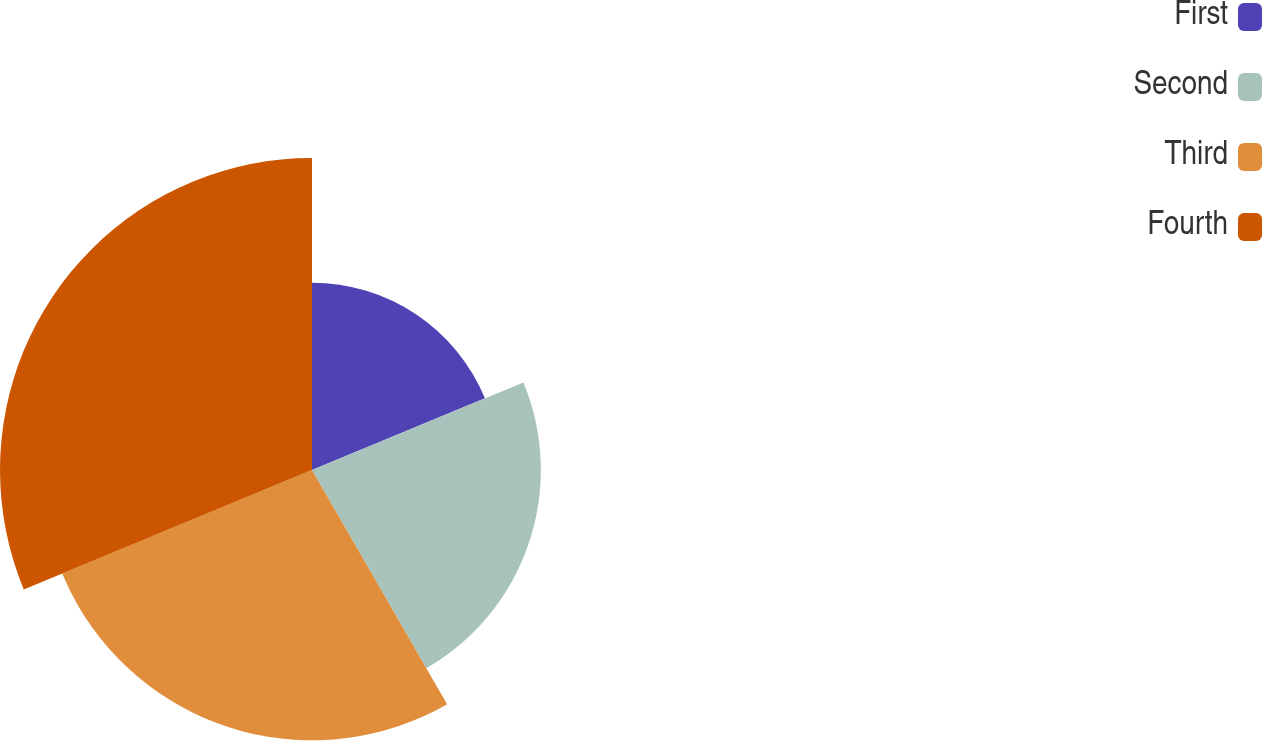Convert chart. <chart><loc_0><loc_0><loc_500><loc_500><pie_chart><fcel>First<fcel>Second<fcel>Third<fcel>Fourth<nl><fcel>18.75%<fcel>22.92%<fcel>27.08%<fcel>31.25%<nl></chart> 